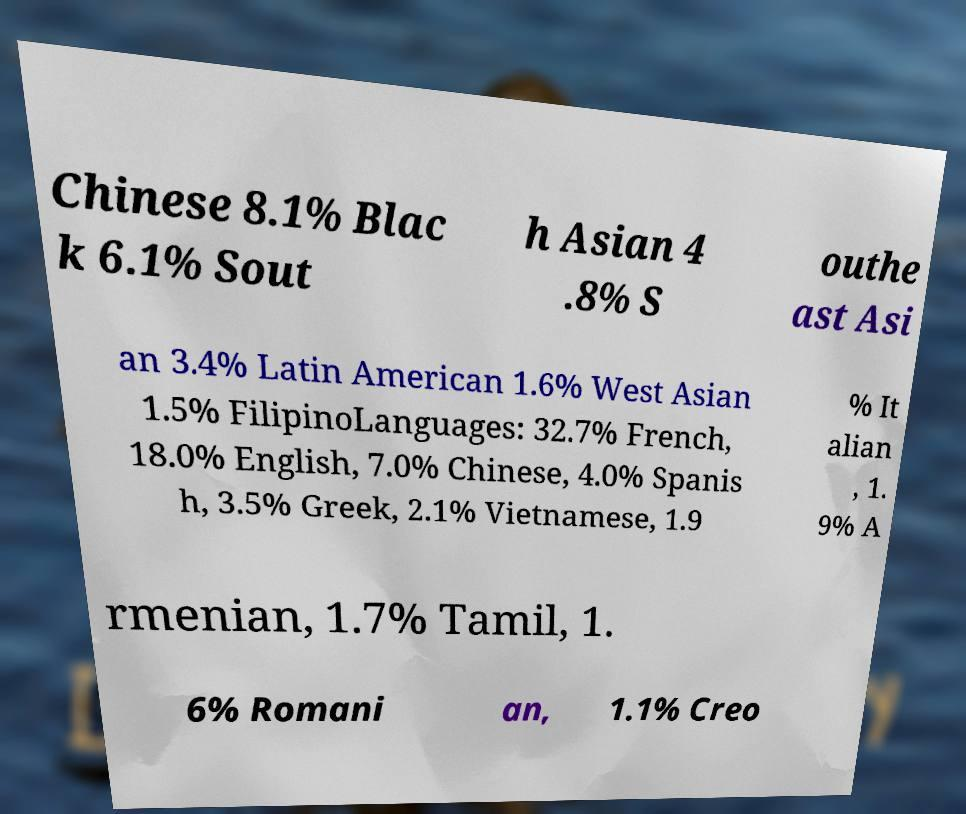There's text embedded in this image that I need extracted. Can you transcribe it verbatim? Chinese 8.1% Blac k 6.1% Sout h Asian 4 .8% S outhe ast Asi an 3.4% Latin American 1.6% West Asian 1.5% FilipinoLanguages: 32.7% French, 18.0% English, 7.0% Chinese, 4.0% Spanis h, 3.5% Greek, 2.1% Vietnamese, 1.9 % It alian , 1. 9% A rmenian, 1.7% Tamil, 1. 6% Romani an, 1.1% Creo 